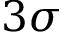<formula> <loc_0><loc_0><loc_500><loc_500>3 \sigma</formula> 